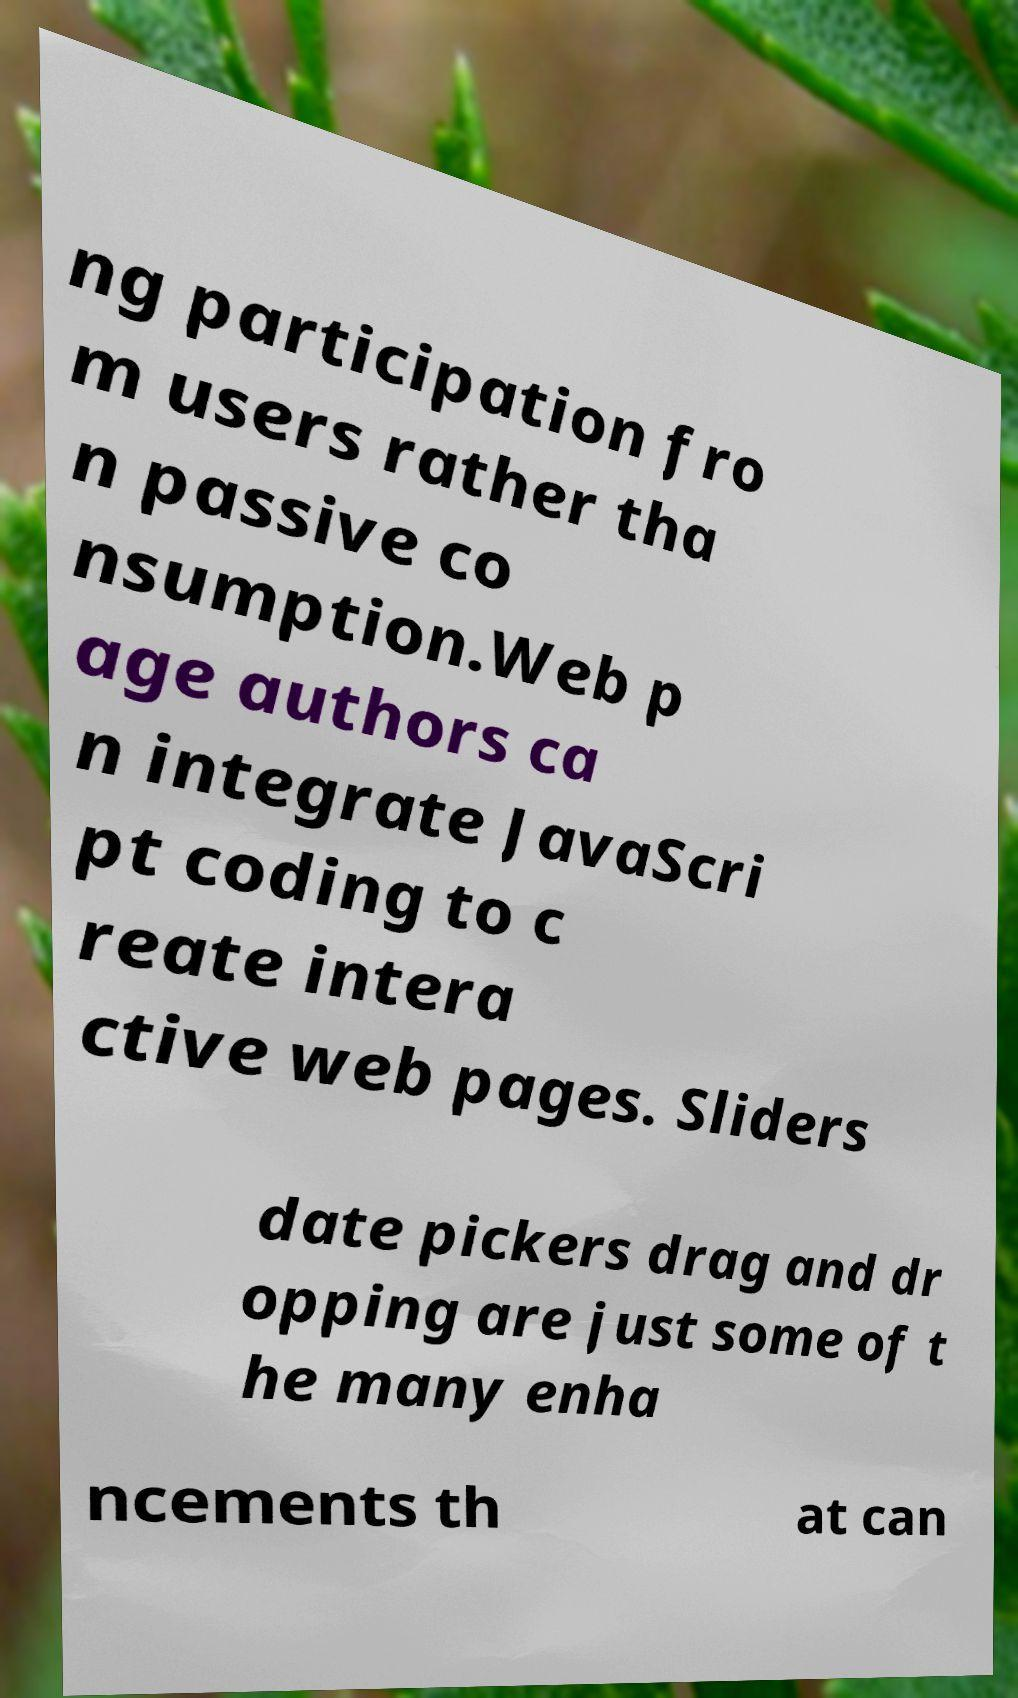Please identify and transcribe the text found in this image. ng participation fro m users rather tha n passive co nsumption.Web p age authors ca n integrate JavaScri pt coding to c reate intera ctive web pages. Sliders date pickers drag and dr opping are just some of t he many enha ncements th at can 